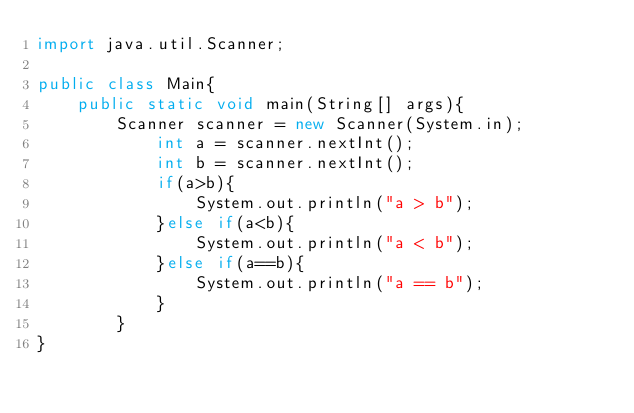<code> <loc_0><loc_0><loc_500><loc_500><_Java_>import java.util.Scanner;

public class Main{ 
    public static void main(String[] args){
        Scanner scanner = new Scanner(System.in);
            int a = scanner.nextInt();
            int b = scanner.nextInt();
            if(a>b){
                System.out.println("a > b");
            }else if(a<b){
                System.out.println("a < b");
            }else if(a==b){
                System.out.println("a == b");
            }
        }
}
</code> 